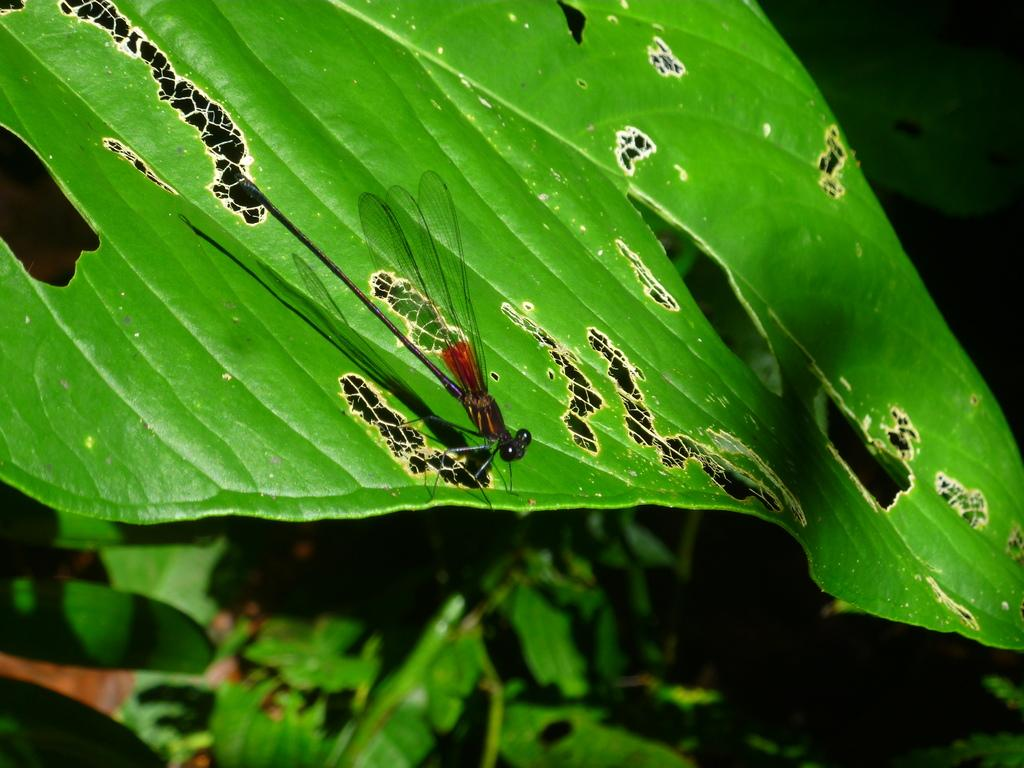What type of creature is present in the image? There is an insect in the image. What is the insect sitting on in the image? There is a leaf in the image. What can be seen in the background of the image? There are leaves in the background of the image. What flavor of juice is the insect drinking in the image? There is no juice present in the image, and therefore no flavor can be determined. 